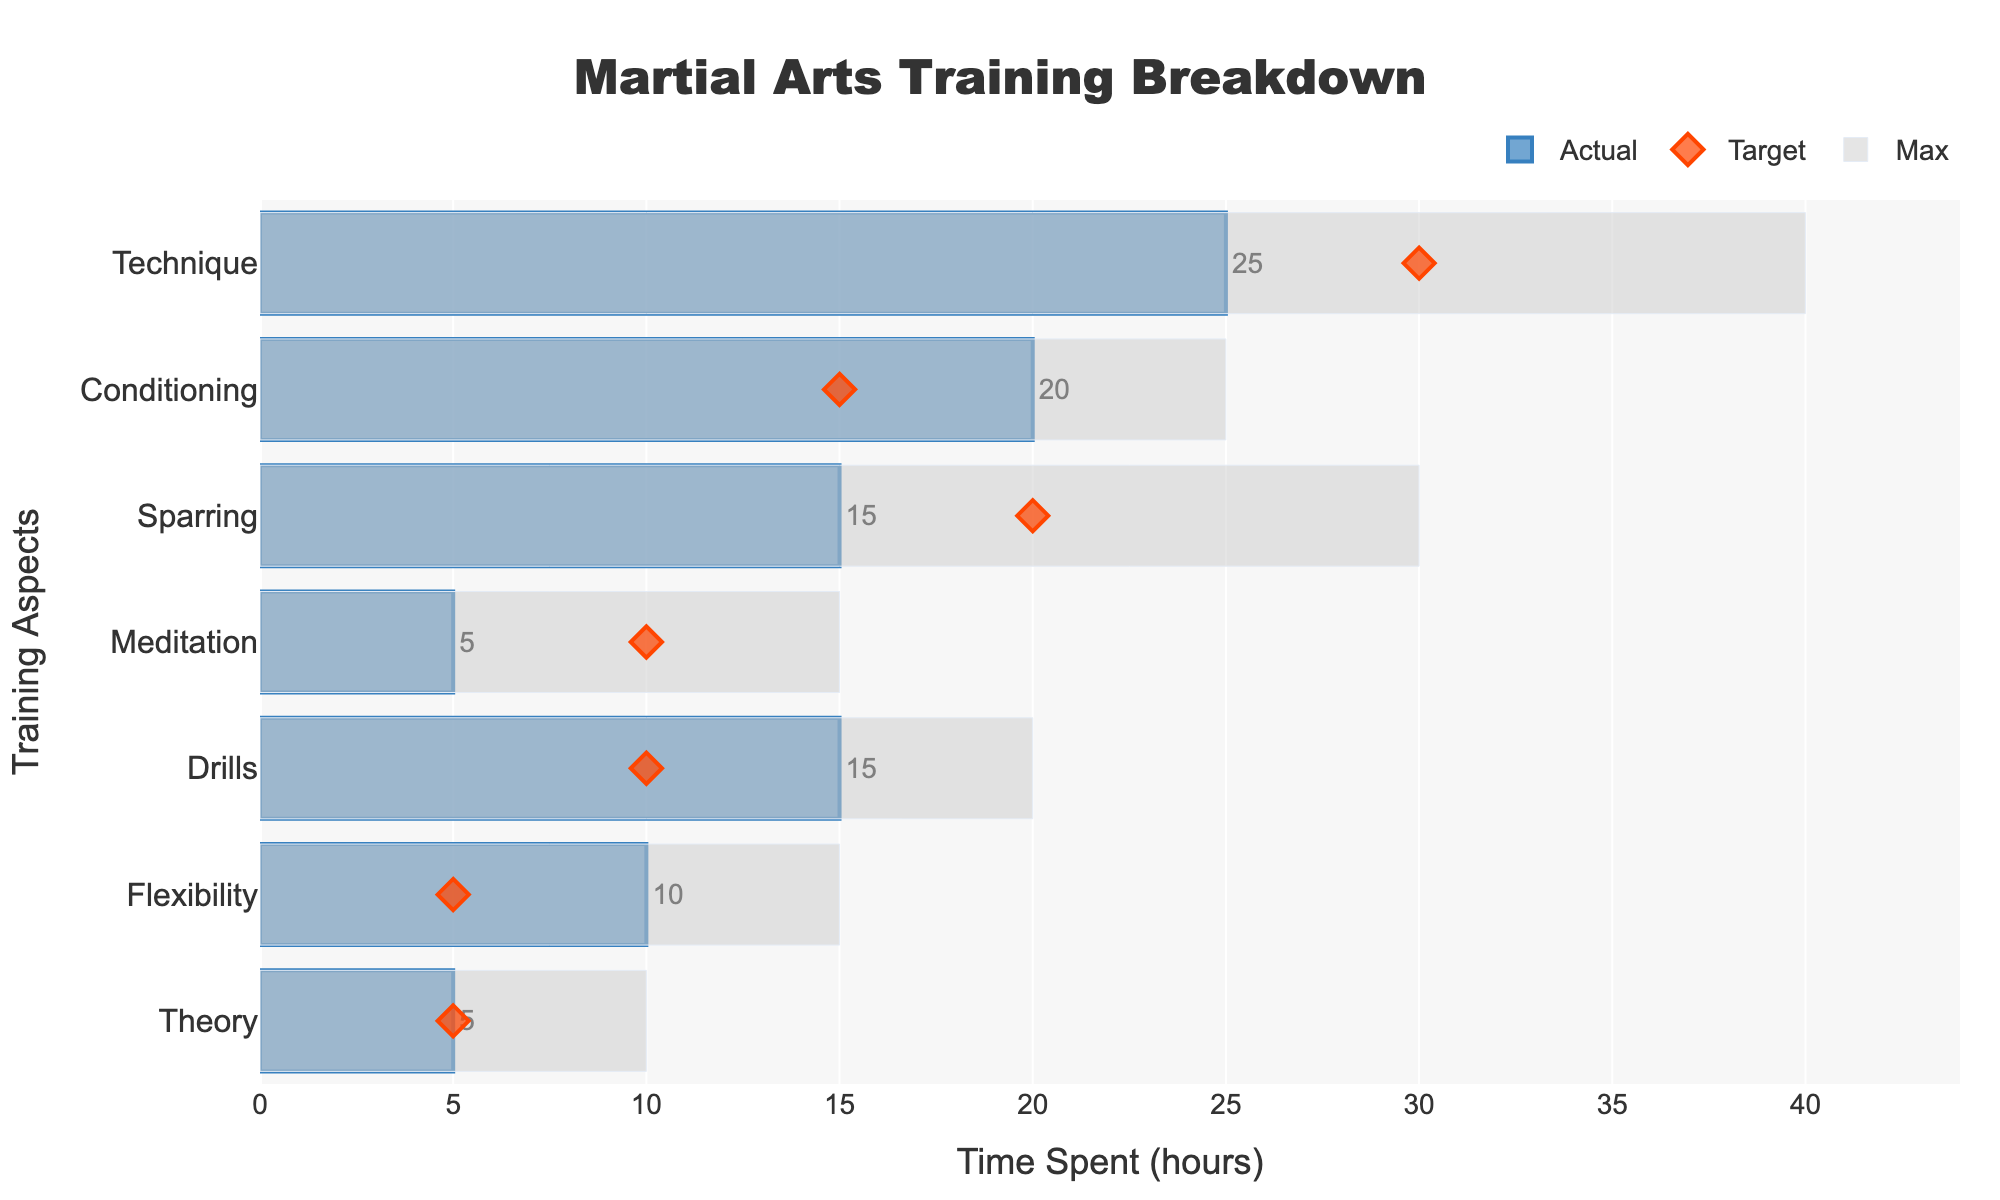What's the title of the figure? The title is usually located at the top of the figure. Here, it reads "Martial Arts Training Breakdown".
Answer: Martial Arts Training Breakdown Which training aspect has the highest 'Actual' value? Look at the bars representing 'Actual' values. The longest bar is for 'Technique' with an 'Actual' value of 25.
Answer: Technique How much more time was spent on Conditioning compared to the target? The 'Actual' value for Conditioning is 20, and the 'Target' value is 15. The difference is 20 - 15.
Answer: 5 hours Compare the 'Actual' and 'Target' values for Sparring. Which is greater, and by how much? The 'Actual' value for Sparring is 15, and the 'Target' value is 20. The 'Target' is greater than the 'Actual' by 20 - 15.
Answer: The Target is greater by 5 hours How does the time spent on Meditation compare with its maximum possible value? The 'Actual' value for Meditation is 5, and the 'Max' value is 15. Compare 5 to 15.
Answer: 10 hours less What proportion of the Target value was achieved for Flexibility? The 'Actual' value for Flexibility is 10, and the 'Target' value is 5. Divide 'Actual' by 'Target': 10 / 5 = 2.
Answer: 200% Which aspect of training has the closest 'Actual' value to its 'Target'? Compare the difference between 'Actual' and 'Target' for each training aspect. 'Theory' has an 'Actual' value of 5 and a 'Target' value of 5, so the difference is 0.
Answer: Theory How much total time is allocated for 'Conditioning' and 'Drills'? Summing 'Actual' values for 'Conditioning' (20) and 'Drills' (15) gives 35.
Answer: 35 hours What is the average 'Target' time across all training aspects? Sum all 'Target' values: 30 + 15 + 20 + 10 + 10 + 5 + 5 = 95. Divide by the number of aspects (7): 95 / 7 ≈ 13.57.
Answer: 13.57 hours If the time spent on Flexibility was doubled, would it exceed its maximum possible time? Doubling Flexibility's 'Actual' value (10) gives 20. Compare 20 to its 'Max' value, which is 15.
Answer: Yes, it would exceed by 5 hours 